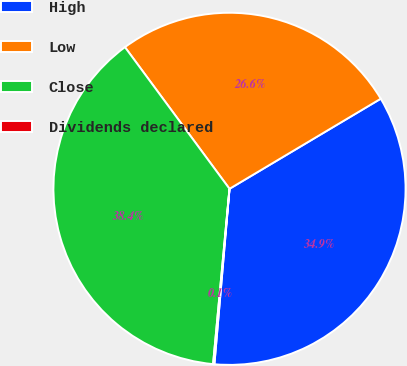Convert chart to OTSL. <chart><loc_0><loc_0><loc_500><loc_500><pie_chart><fcel>High<fcel>Low<fcel>Close<fcel>Dividends declared<nl><fcel>34.92%<fcel>26.57%<fcel>38.4%<fcel>0.12%<nl></chart> 